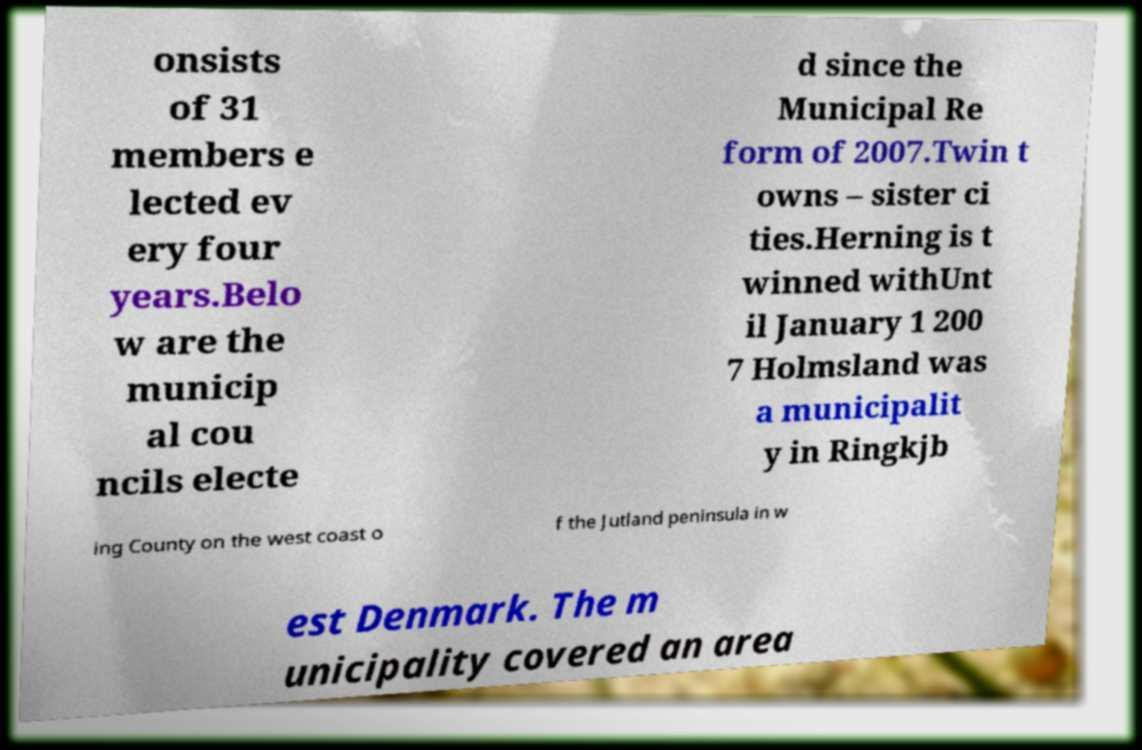Could you extract and type out the text from this image? onsists of 31 members e lected ev ery four years.Belo w are the municip al cou ncils electe d since the Municipal Re form of 2007.Twin t owns – sister ci ties.Herning is t winned withUnt il January 1 200 7 Holmsland was a municipalit y in Ringkjb ing County on the west coast o f the Jutland peninsula in w est Denmark. The m unicipality covered an area 